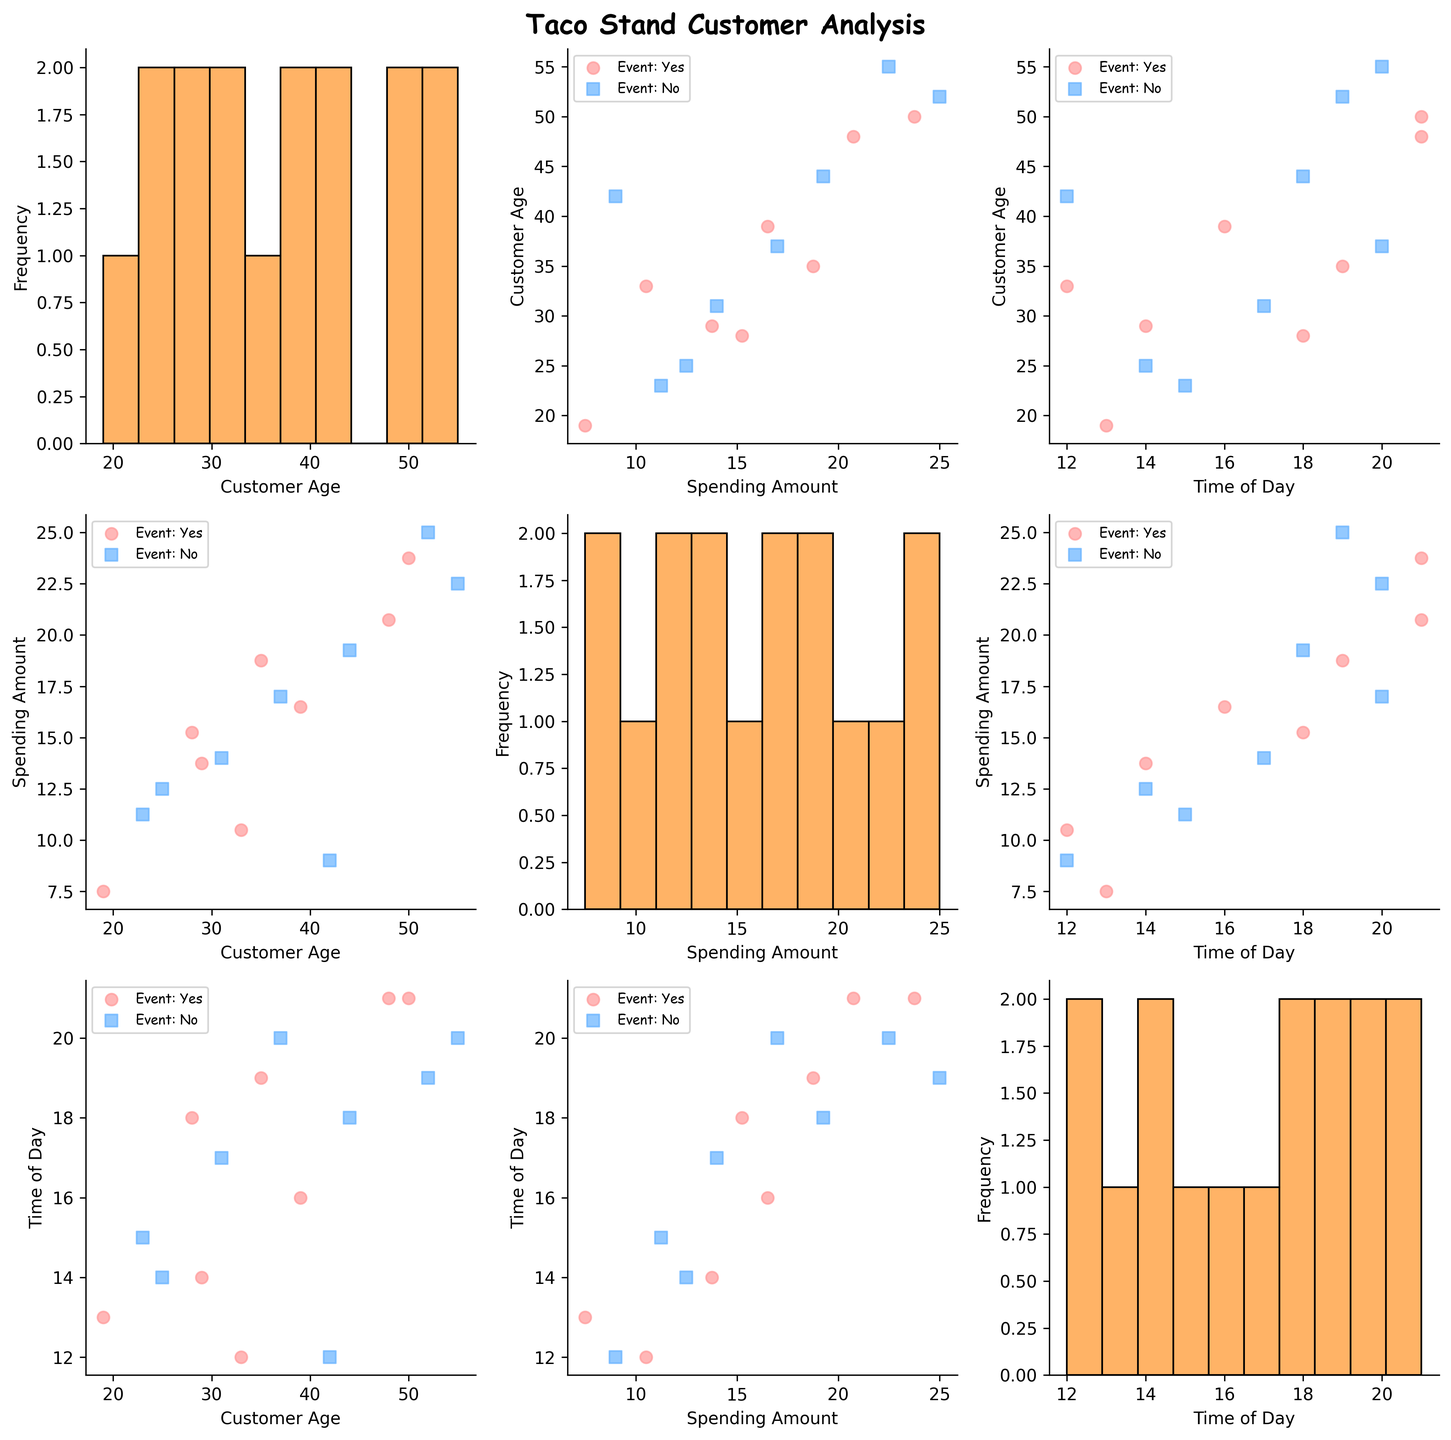What is the title of the figure? The title is usually displayed at the top of the figure. Look for the text at the top that summarizes the contents of the scatterplot matrix.
Answer: Taco Stand Customer Analysis How many bins are used in the histogram for the 'Customer Age' variable? Each histogram plot in the scatterplot matrix shows the frequency distribution of a single variable and the number of bars (bins) can be counted visually.
Answer: 10 Which time of day had the highest spending amount? Locate the scatter plots where 'Time of Day' is on the x-axis and 'Spending Amount' is on the y-axis. Identify the point with the highest y-value and note the corresponding x-value.
Answer: 21 Are cleanup event attendees younger, on average, than non-attendees? Compare the scatter plots where 'Customer Age' is a variable, and two colors differentiate cleanup event attendees and non-attendees. Assess the positioning of each group along the 'Customer Age' axis to determine which group tends to have lower values.
Answer: Yes What is the range of 'Spending Amount' for customers attending cleanup events? Identify the points representing cleanup event attendees from the scatter plots with 'Spending Amount' on one of the axes. Note the minimum and maximum values these points reach on the 'Spending Amount' axis.
Answer: 7.50 to 23.75 Which combination of characteristics is the most visually distinct in the scatterplot matrix? Examine the scatter plots for instances of clear separation between different groups (e.g., different colors or markers). Identify which combination of characteristics (such as 'Spending Amount' vs. 'Customer Age') shows the most distinct separation.
Answer: Cleanup Event Attendee vs. Non-Attendee Is there a noticeable spending trend based on customer age? Look at the scatter plots where 'Customer Age' is an axis variable and 'Spending Amount' is the other variable. Observe if there is a pattern or trend that correlates age with spending.
Answer: No clear trend How does the frequency distribution of 'Time of Day' look? Refer to the histogram for 'Time of Day' to identify the distribution pattern. Note the number of bars and their heights to describe the shape.
Answer: Spread across the day with no single peak What is the typical spending range for customers aged around 30? Focus on the scatter plots where 'Customer Age' is near 30 along the axis and observe the values of 'Spending Amount' for these points. Identify the range these points fall into.
Answer: 12.50 to 17.00 